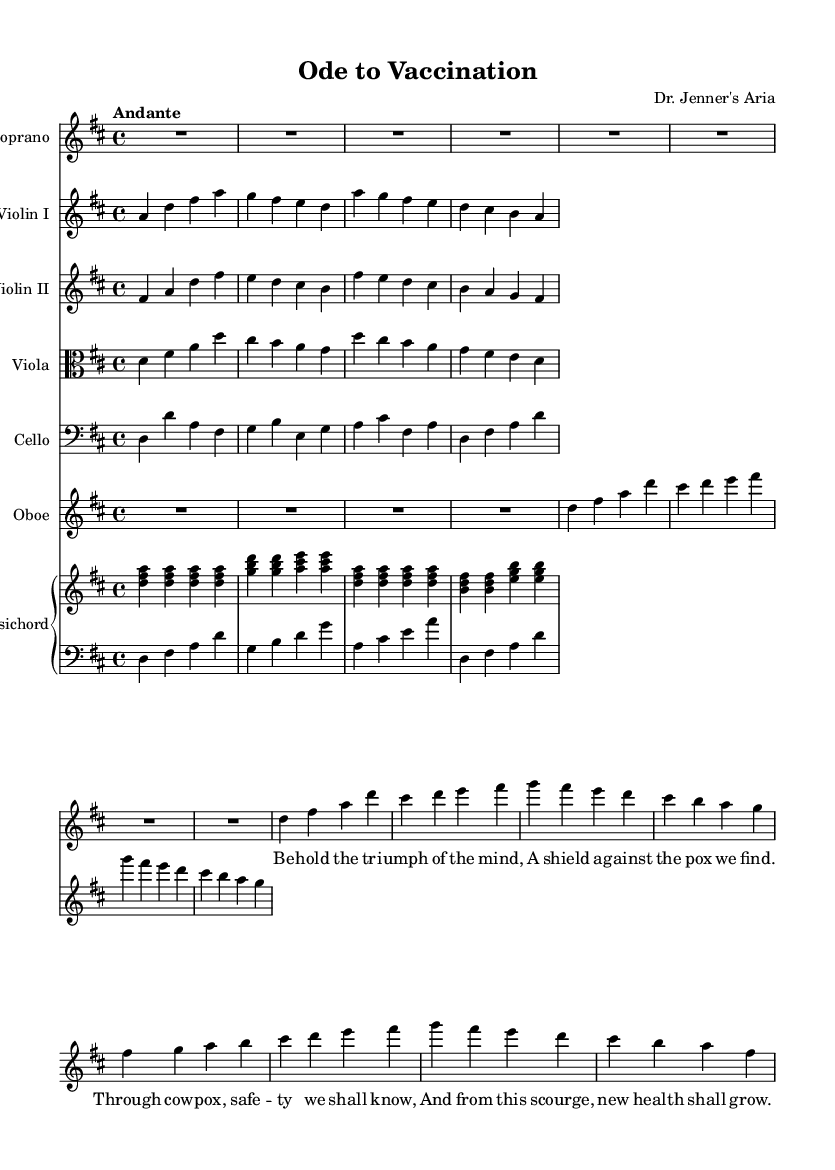What is the key signature of this music? The key signature is D major, which has two sharps (F# and C#). This can be inferred from the notation found at the beginning of the score.
Answer: D major What is the time signature of this composition? The time signature is 4/4, as indicated at the beginning of the score, which means there are four beats in each measure and a quarter note gets one beat.
Answer: 4/4 What is the tempo marking of the piece? The tempo marking is "Andante," which is indicated in the score and typically denotes a moderately slow tempo.
Answer: Andante How many measures are in the soprano part? The soprano part consists of eight measures, which can be counted by examining the segments divided by the vertical bar lines in the staff.
Answer: Eight Which instrument plays the melody alongside the soprano? The Oboe plays the melody along with the soprano, as both parts share similar pitches and rhythms, creating a conversation-like texture within the composition.
Answer: Oboe What is the thematic focus of the lyrics? The thematic focus of the lyrics revolves around vaccination, highlighting the triumph of the mind and the protective nature against diseases such as smallpox. This can be inferred from the textual content of the lyrics themselves.
Answer: Vaccination How does the structure of this composition reflect Baroque opera conventions? This composition reflects Baroque opera conventions through its use of distinct vocal and instrumental lines, with a clear emphasis on a narrative conveyed by the soprano's lyrics, mimicking operatic storytelling. The orchestration and lyrical content align with the historical context of celebrating scientific advancements.
Answer: Operatic conventions 